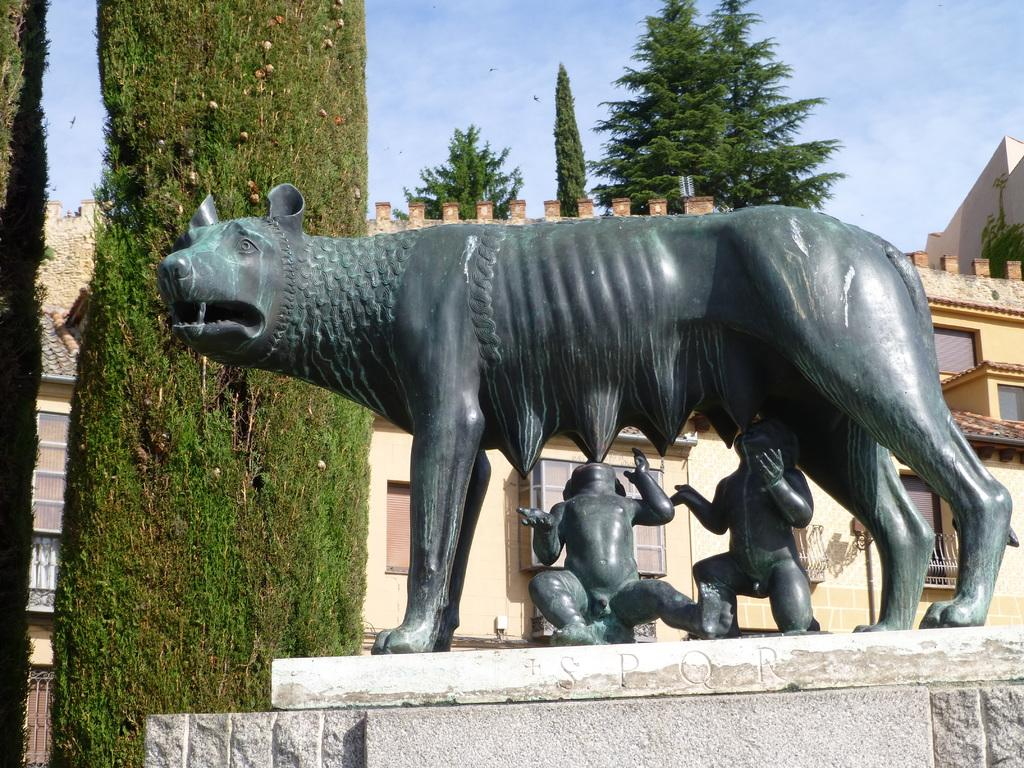What is the main subject in the image? There is a statue in the image. What can be seen in the background of the image? There is a building and trees in the background of the image. What is the cause of the butter melting in the image? There is no butter present in the image, so it is not possible to determine the cause of any melting. 